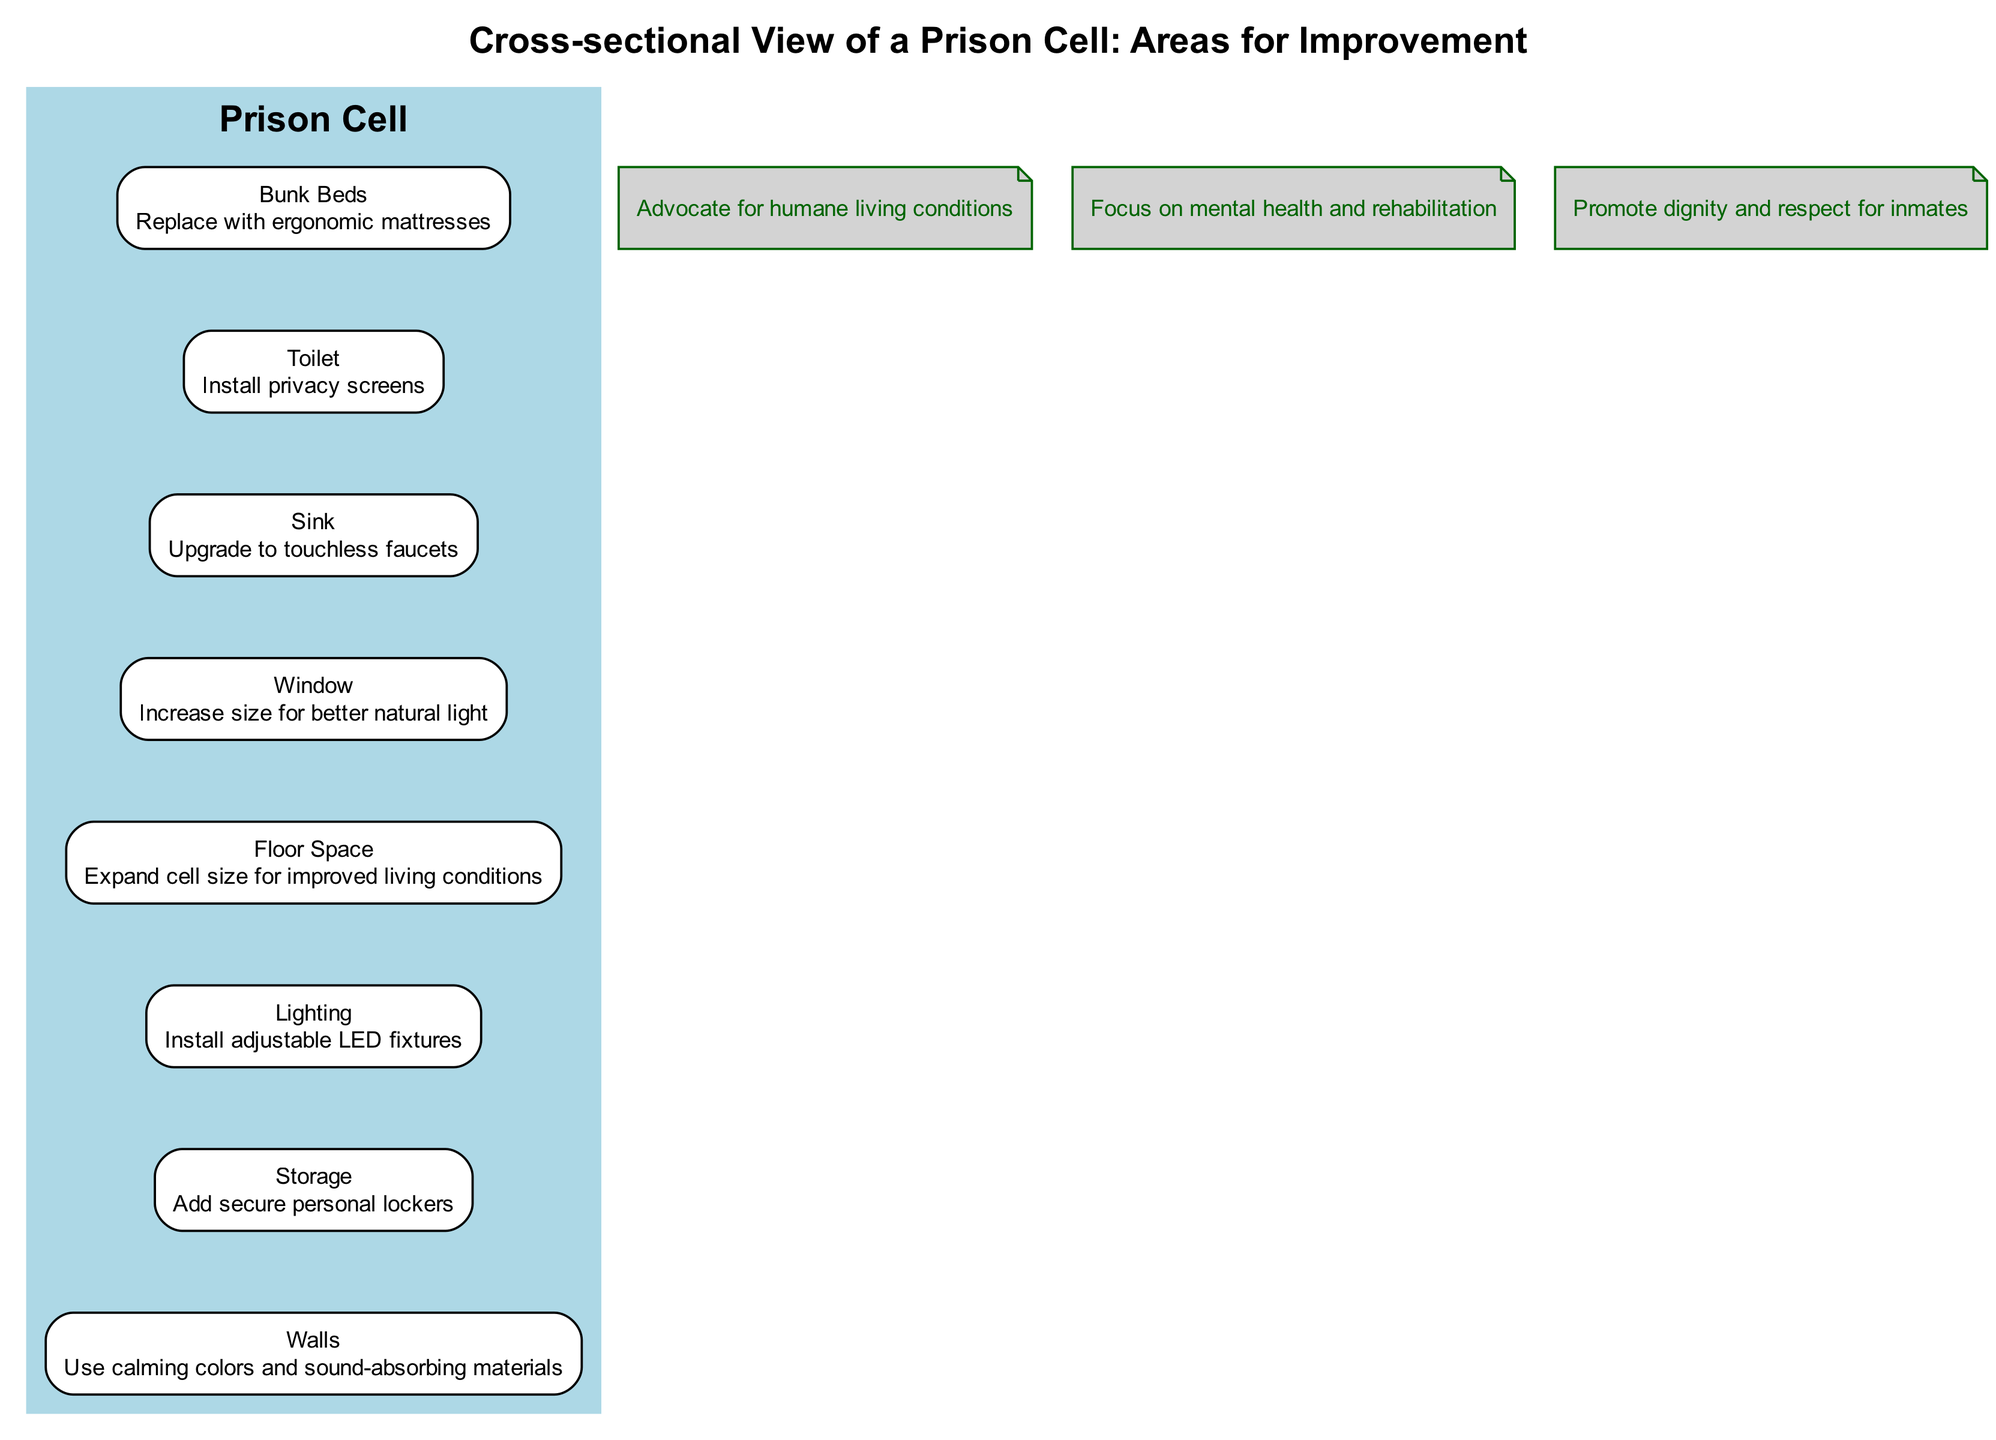What is the proposed improvement for the bunk beds? The diagram states "Replace with ergonomic mattresses" as the improvement for the bunk beds, indicating a change aimed at enhancing comfort.
Answer: Replace with ergonomic mattresses How many components are highlighted in the cell layout? The diagram lists a total of eight cell components: bunk beds, toilet, sink, window, floor space, lighting, storage, and walls.
Answer: Eight Which area should have privacy screens installed? According to the diagram, privacy screens need to be installed around the toilet area to enhance personal privacy for inmates.
Answer: Toilet What color is recommended for the walls? The diagram suggests using "calming colors and sound-absorbing materials" for the walls to create a more peaceful environment for inmates.
Answer: Calming colors Explain the relationship between the window and the floor space. The edges connecting the window to floor space are only visible and indicate the sequential order of areas in the cell. The window contributes to the overall environmental quality, while the floor space emphasizes the need for a spacious living area.
Answer: Sequential connection What is the improvement suggested for the lighting in the cell? The diagram indicates that the lighting should be upgraded to "Install adjustable LED fixtures," enhancing energy efficiency and adaptability.
Answer: Install adjustable LED fixtures How does the diagram advocate for inmate welfare? The annotations suggest a focus on humane living conditions, mental health, and respect for inmates, framing the diagram's design as a part of broader advocacy efforts.
Answer: Humane living conditions, mental health, respect What type of faucets are recommended for the sink? The diagram suggests upgrading to "touchless faucets" for the sink to promote hygiene and reduce contact.
Answer: Touchless faucets What is highlighted as an essential addition for storage? According to the diagram, the addition of "secure personal lockers" is emphasized, indicating the importance of personal security and organization for inmates' belongings.
Answer: Secure personal lockers 